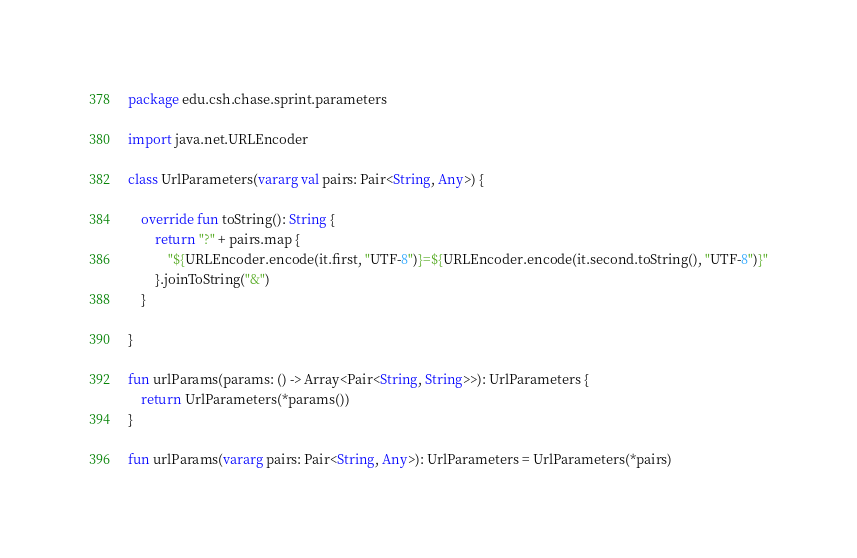<code> <loc_0><loc_0><loc_500><loc_500><_Kotlin_>package edu.csh.chase.sprint.parameters

import java.net.URLEncoder

class UrlParameters(vararg val pairs: Pair<String, Any>) {

    override fun toString(): String {
        return "?" + pairs.map {
            "${URLEncoder.encode(it.first, "UTF-8")}=${URLEncoder.encode(it.second.toString(), "UTF-8")}"
        }.joinToString("&")
    }

}

fun urlParams(params: () -> Array<Pair<String, String>>): UrlParameters {
    return UrlParameters(*params())
}

fun urlParams(vararg pairs: Pair<String, Any>): UrlParameters = UrlParameters(*pairs)</code> 